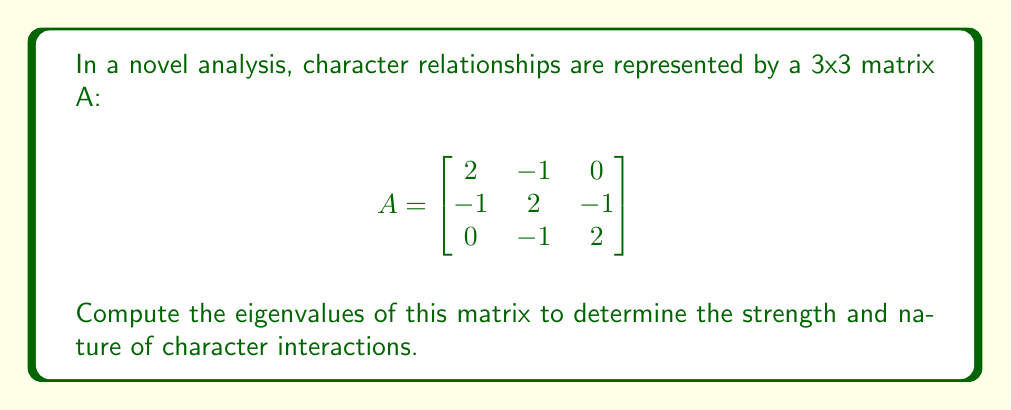Help me with this question. To find the eigenvalues of matrix A, we need to solve the characteristic equation:

1) First, we form the characteristic polynomial:
   $$det(A - \lambda I) = 0$$
   where $I$ is the 3x3 identity matrix and $\lambda$ represents the eigenvalues.

2) Expanding the determinant:
   $$det\begin{bmatrix}
   2-\lambda & -1 & 0 \\
   -1 & 2-\lambda & -1 \\
   0 & -1 & 2-\lambda
   \end{bmatrix} = 0$$

3) Calculate the determinant:
   $$(2-\lambda)[(2-\lambda)(2-\lambda) - 1] - (-1)[(-1)(2-\lambda) - 0] = 0$$

4) Simplify:
   $$(2-\lambda)[(2-\lambda)^2 - 1] + (2-\lambda) = 0$$
   $$(2-\lambda)[(2-\lambda)^2 - 1 + 1] = 0$$
   $$(2-\lambda)(2-\lambda)^2 = 0$$

5) Factor the equation:
   $$(2-\lambda)(2-\lambda)(2-\lambda) = 0$$
   $$(2-\lambda)^3 = 0$$

6) Solve for $\lambda$:
   $$2-\lambda = 0$$
   $$\lambda = 2$$

Therefore, the eigenvalue of matrix A is 2, with algebraic multiplicity 3.
Answer: $\lambda = 2$ (with algebraic multiplicity 3) 